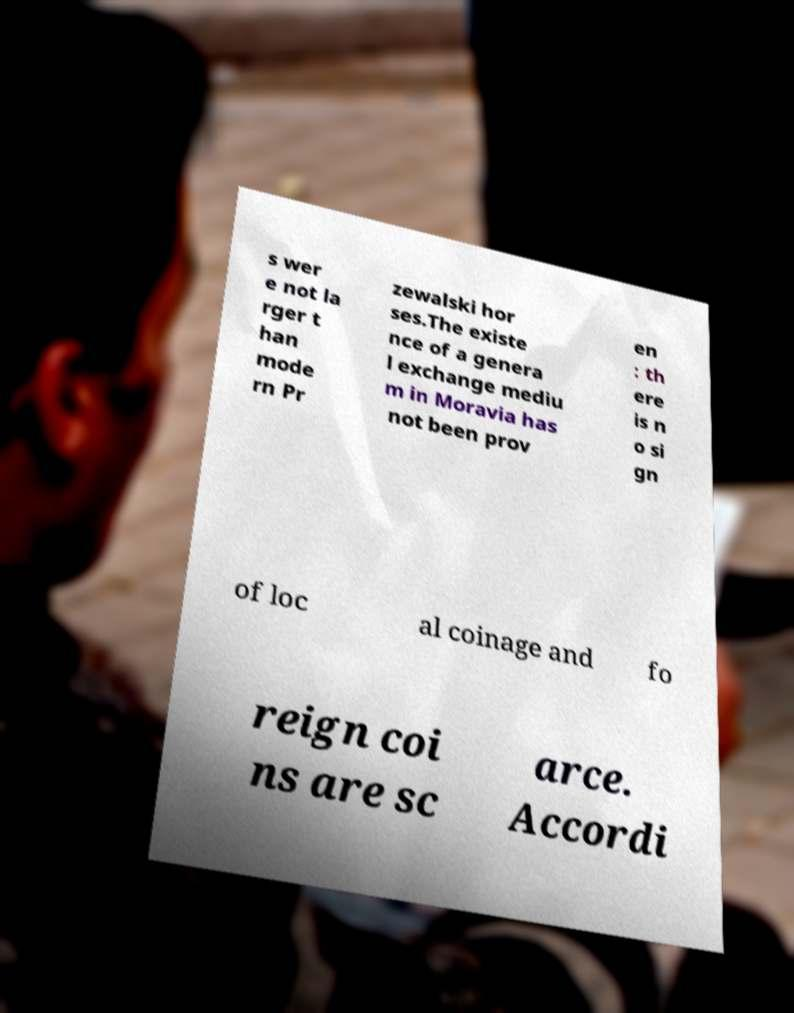I need the written content from this picture converted into text. Can you do that? s wer e not la rger t han mode rn Pr zewalski hor ses.The existe nce of a genera l exchange mediu m in Moravia has not been prov en : th ere is n o si gn of loc al coinage and fo reign coi ns are sc arce. Accordi 